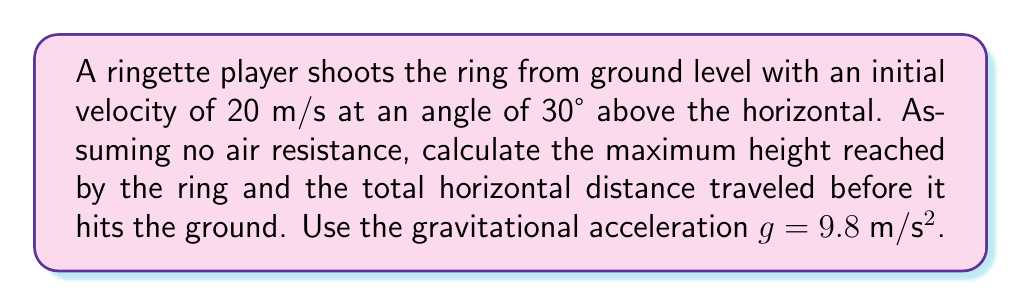Can you answer this question? Let's approach this step-by-step using the equations of projectile motion:

1) The trajectory of the ring can be described by a parabolic function. We'll use:
   $$y = x \tan\theta - \frac{gx^2}{2(v_0 \cos\theta)^2}$$
   where $y$ is the vertical position, $x$ is the horizontal position, $\theta$ is the launch angle, $v_0$ is the initial velocity, and $g$ is the gravitational acceleration.

2) For the maximum height:
   a) Use the equation: $h_{max} = \frac{(v_0 \sin\theta)^2}{2g}$
   b) $\theta = 30°$, $v_0 = 20$ m/s, $g = 9.8$ m/s²
   c) $h_{max} = \frac{(20 \sin30°)^2}{2(9.8)} = \frac{100}{2(9.8)} = 5.10$ m

3) For the total horizontal distance (range):
   a) Use the equation: $R = \frac{v_0^2 \sin2\theta}{g}$
   b) $R = \frac{20^2 \sin60°}{9.8} = \frac{400(0.866)}{9.8} = 35.31$ m

[asy]
import graph;
size(200,150);
real f(real x) {return x*tan(pi/6) - 4.9*x^2/(400*cos(pi/6)^2);}
draw(graph(f,0,35.31));
draw((0,0)--(35.31,0),arrow=Arrow(TeXHead));
draw((0,0)--(0,5.10),arrow=Arrow(TeXHead));
label("35.31 m",(17.65,-0.5),S);
label("5.10 m",(-0.5,2.55),W);
[/asy]
Answer: Maximum height: 5.10 m; Horizontal distance: 35.31 m 